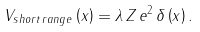<formula> <loc_0><loc_0><loc_500><loc_500>V _ { s h o r t \, r a n g e } \left ( x \right ) = \lambda \, Z \, e ^ { 2 \, } \delta \left ( x \right ) .</formula> 